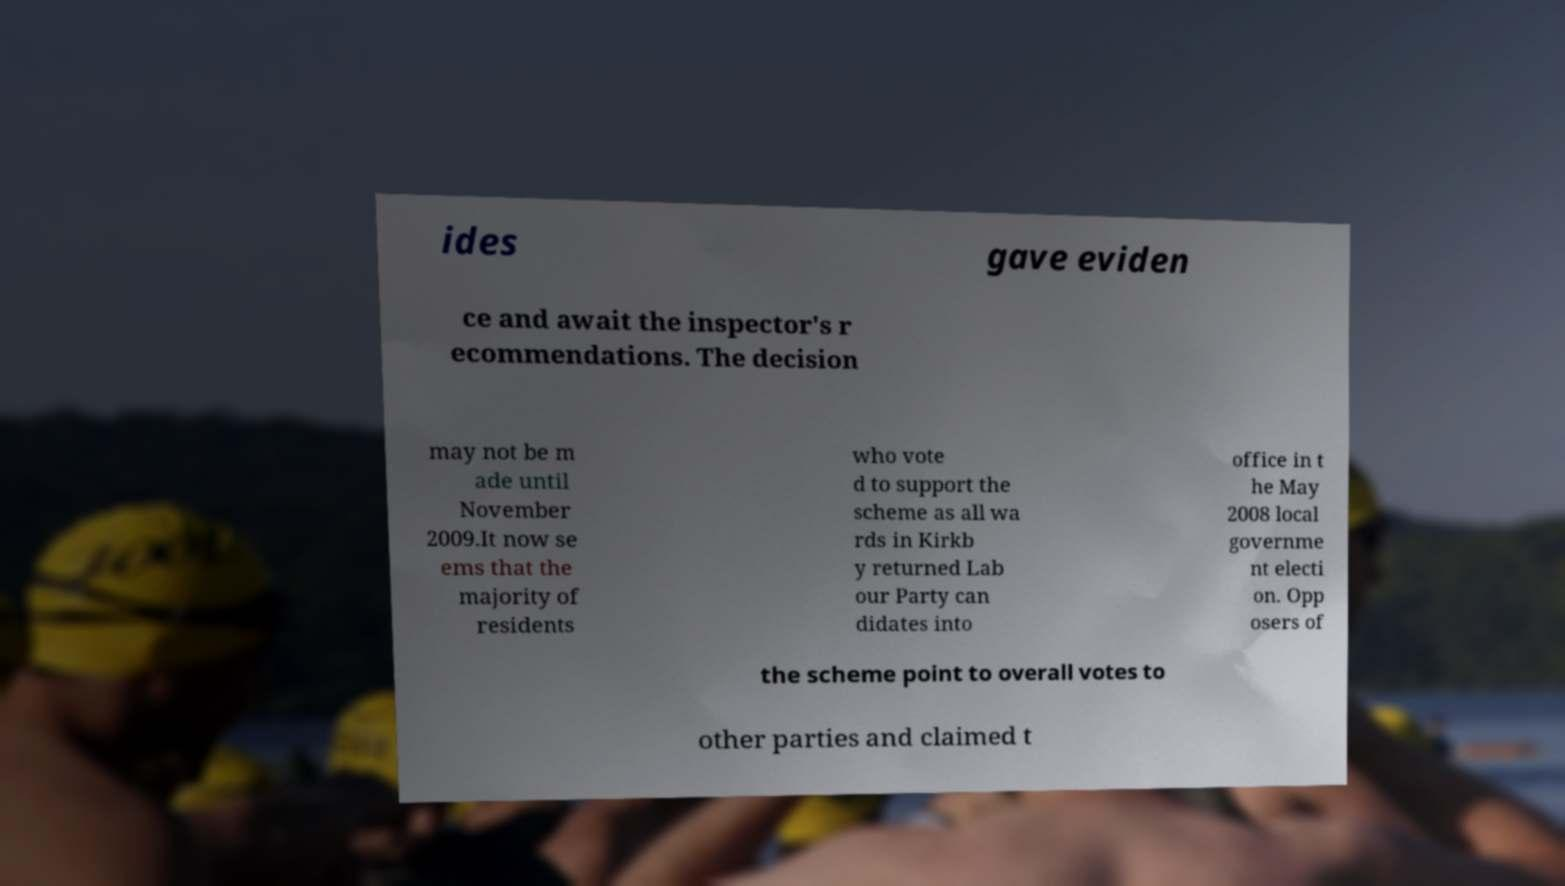What messages or text are displayed in this image? I need them in a readable, typed format. ides gave eviden ce and await the inspector's r ecommendations. The decision may not be m ade until November 2009.It now se ems that the majority of residents who vote d to support the scheme as all wa rds in Kirkb y returned Lab our Party can didates into office in t he May 2008 local governme nt electi on. Opp osers of the scheme point to overall votes to other parties and claimed t 